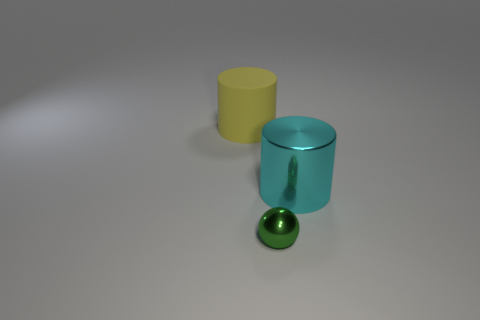Are the large object to the right of the yellow matte cylinder and the small green object that is in front of the yellow rubber cylinder made of the same material?
Your answer should be very brief. Yes. What number of small green metallic objects are behind the large shiny cylinder?
Ensure brevity in your answer.  0. Is the large cyan thing made of the same material as the object that is in front of the cyan object?
Make the answer very short. Yes. What is the size of the green ball that is the same material as the large cyan thing?
Provide a short and direct response. Small. Is the number of large cylinders that are behind the big cyan metallic object greater than the number of yellow things that are right of the big matte cylinder?
Give a very brief answer. Yes. Are there any large yellow objects that have the same shape as the cyan metallic object?
Make the answer very short. Yes. Is the size of the cylinder in front of the yellow rubber object the same as the green shiny thing?
Your answer should be very brief. No. Are there any tiny green balls?
Provide a succinct answer. Yes. What number of objects are cylinders to the left of the small metal ball or large matte cubes?
Offer a terse response. 1. Is there a object of the same size as the cyan metallic cylinder?
Ensure brevity in your answer.  Yes. 